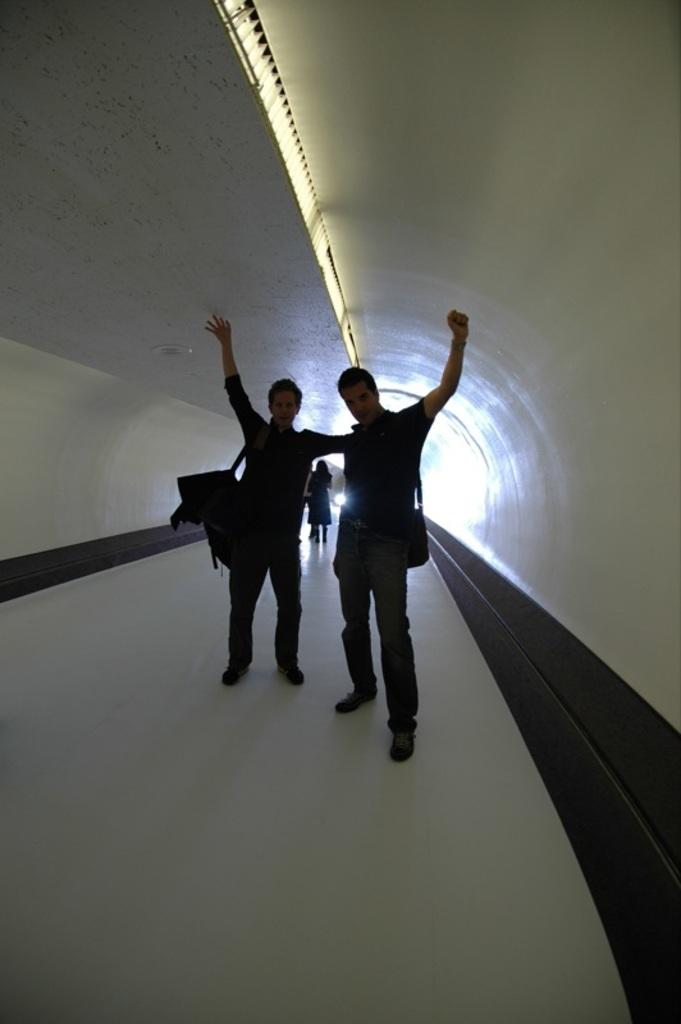What can be seen in the image? There are people standing in the image. What else is present in the image besides the people? There are bags in the image. Can you see a crown on any of the people's heads in the image? There is no crown visible on any of the people's heads in the image. 